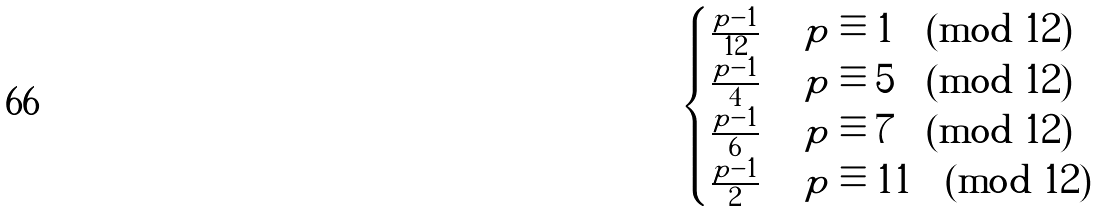Convert formula to latex. <formula><loc_0><loc_0><loc_500><loc_500>\begin{cases} \frac { p - 1 } { 1 2 } & \text { $p \equiv 1 \pmod{12}$} \\ \frac { p - 1 } { 4 } & \text { $p \equiv 5 \pmod{12}$} \\ \frac { p - 1 } { 6 } & \text { $p \equiv 7 \pmod{12}$} \\ \frac { p - 1 } { 2 } & \text { $p \equiv 11 \pmod{12}$} \end{cases}</formula> 